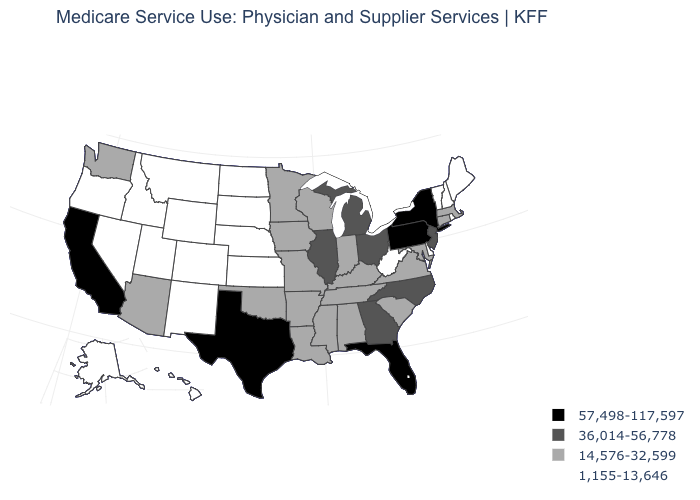Name the states that have a value in the range 14,576-32,599?
Give a very brief answer. Alabama, Arizona, Arkansas, Connecticut, Indiana, Iowa, Kentucky, Louisiana, Maryland, Massachusetts, Minnesota, Mississippi, Missouri, Oklahoma, South Carolina, Tennessee, Virginia, Washington, Wisconsin. What is the value of Alaska?
Write a very short answer. 1,155-13,646. Among the states that border Ohio , does West Virginia have the lowest value?
Write a very short answer. Yes. What is the highest value in states that border Ohio?
Answer briefly. 57,498-117,597. Name the states that have a value in the range 1,155-13,646?
Concise answer only. Alaska, Colorado, Delaware, Hawaii, Idaho, Kansas, Maine, Montana, Nebraska, Nevada, New Hampshire, New Mexico, North Dakota, Oregon, Rhode Island, South Dakota, Utah, Vermont, West Virginia, Wyoming. Does West Virginia have the lowest value in the USA?
Write a very short answer. Yes. What is the value of Idaho?
Concise answer only. 1,155-13,646. How many symbols are there in the legend?
Answer briefly. 4. What is the highest value in the USA?
Quick response, please. 57,498-117,597. Does Florida have the highest value in the South?
Write a very short answer. Yes. Does Minnesota have the highest value in the USA?
Give a very brief answer. No. What is the value of Idaho?
Keep it brief. 1,155-13,646. Does Pennsylvania have the same value as New York?
Quick response, please. Yes. What is the lowest value in the Northeast?
Quick response, please. 1,155-13,646. What is the value of Nebraska?
Be succinct. 1,155-13,646. 